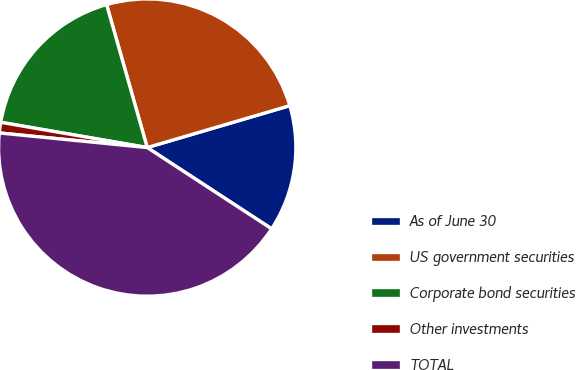Convert chart. <chart><loc_0><loc_0><loc_500><loc_500><pie_chart><fcel>As of June 30<fcel>US government securities<fcel>Corporate bond securities<fcel>Other investments<fcel>TOTAL<nl><fcel>13.76%<fcel>24.86%<fcel>17.88%<fcel>1.15%<fcel>42.36%<nl></chart> 